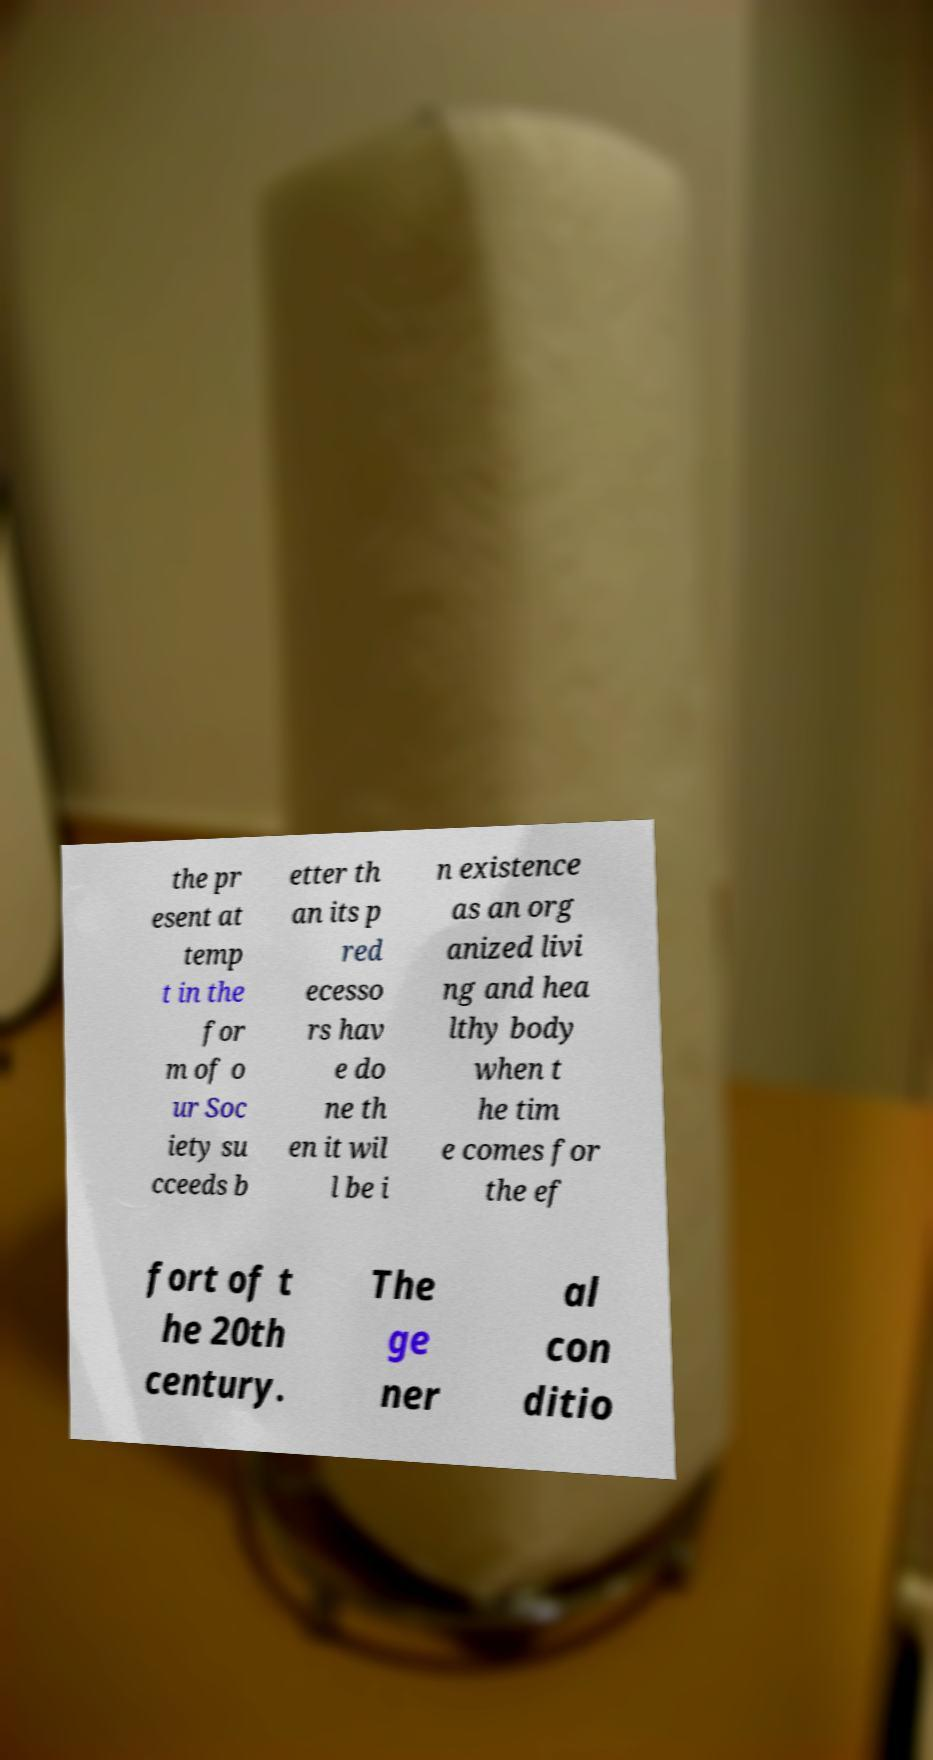Please identify and transcribe the text found in this image. the pr esent at temp t in the for m of o ur Soc iety su cceeds b etter th an its p red ecesso rs hav e do ne th en it wil l be i n existence as an org anized livi ng and hea lthy body when t he tim e comes for the ef fort of t he 20th century. The ge ner al con ditio 